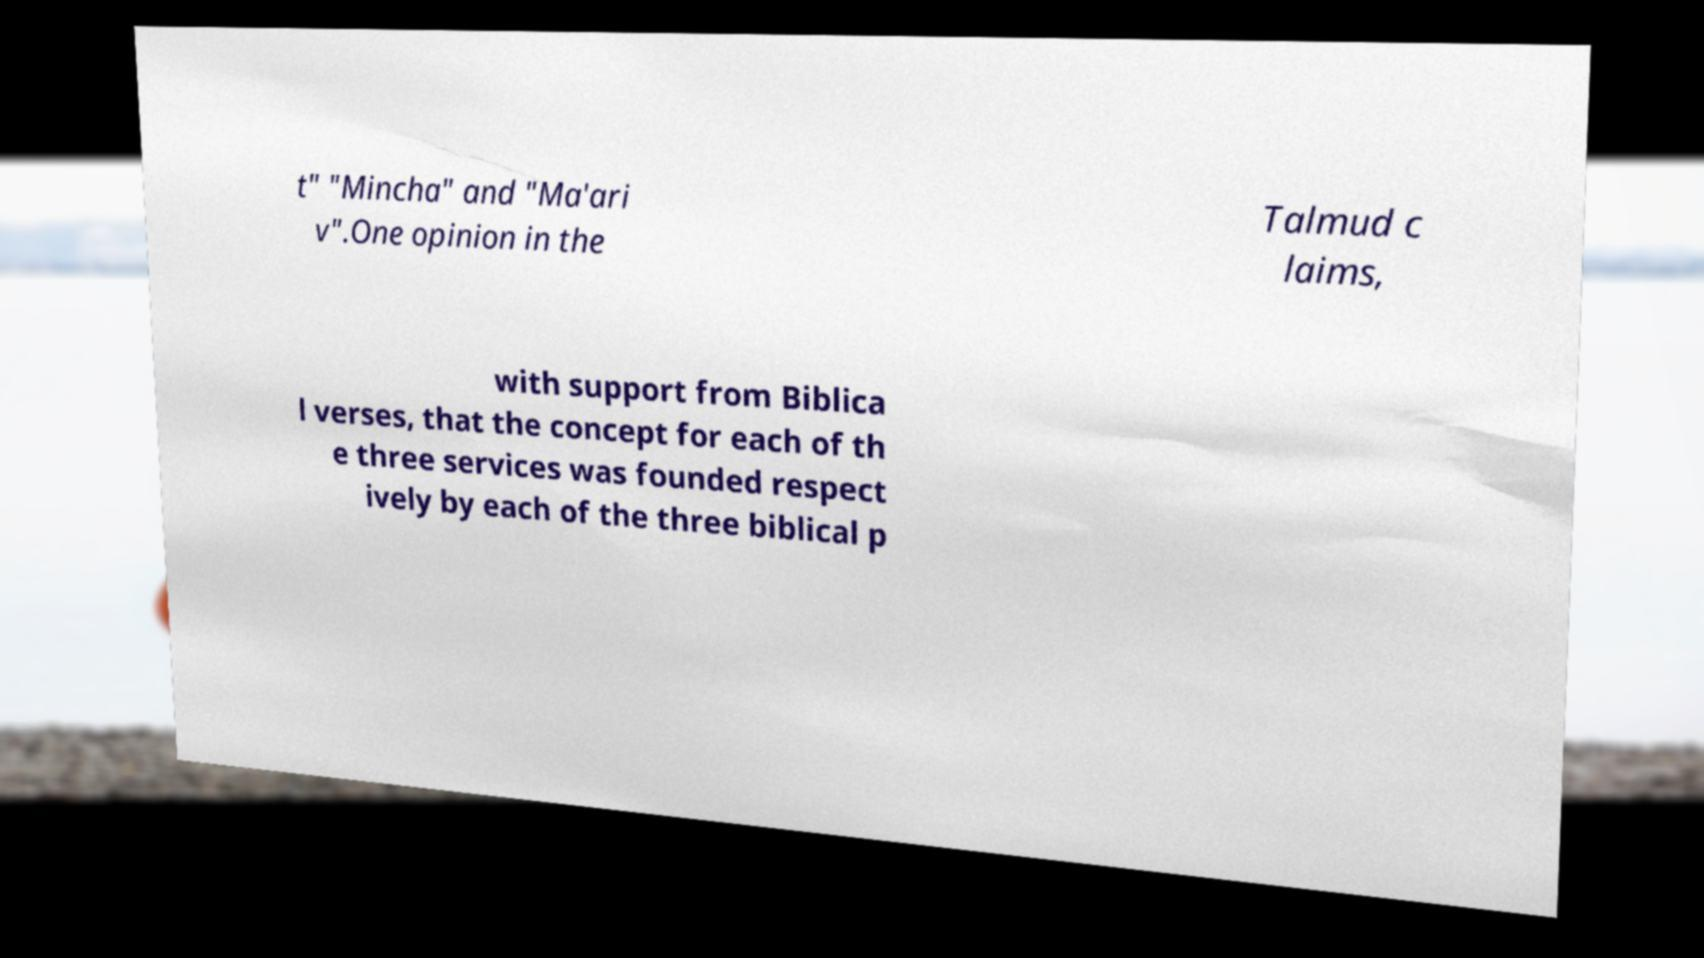For documentation purposes, I need the text within this image transcribed. Could you provide that? t" "Mincha" and "Ma'ari v".One opinion in the Talmud c laims, with support from Biblica l verses, that the concept for each of th e three services was founded respect ively by each of the three biblical p 